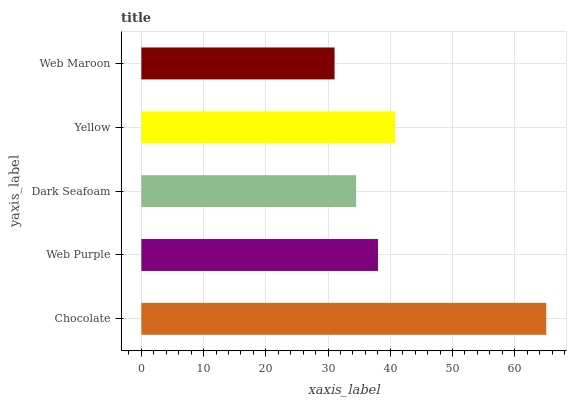Is Web Maroon the minimum?
Answer yes or no. Yes. Is Chocolate the maximum?
Answer yes or no. Yes. Is Web Purple the minimum?
Answer yes or no. No. Is Web Purple the maximum?
Answer yes or no. No. Is Chocolate greater than Web Purple?
Answer yes or no. Yes. Is Web Purple less than Chocolate?
Answer yes or no. Yes. Is Web Purple greater than Chocolate?
Answer yes or no. No. Is Chocolate less than Web Purple?
Answer yes or no. No. Is Web Purple the high median?
Answer yes or no. Yes. Is Web Purple the low median?
Answer yes or no. Yes. Is Web Maroon the high median?
Answer yes or no. No. Is Chocolate the low median?
Answer yes or no. No. 